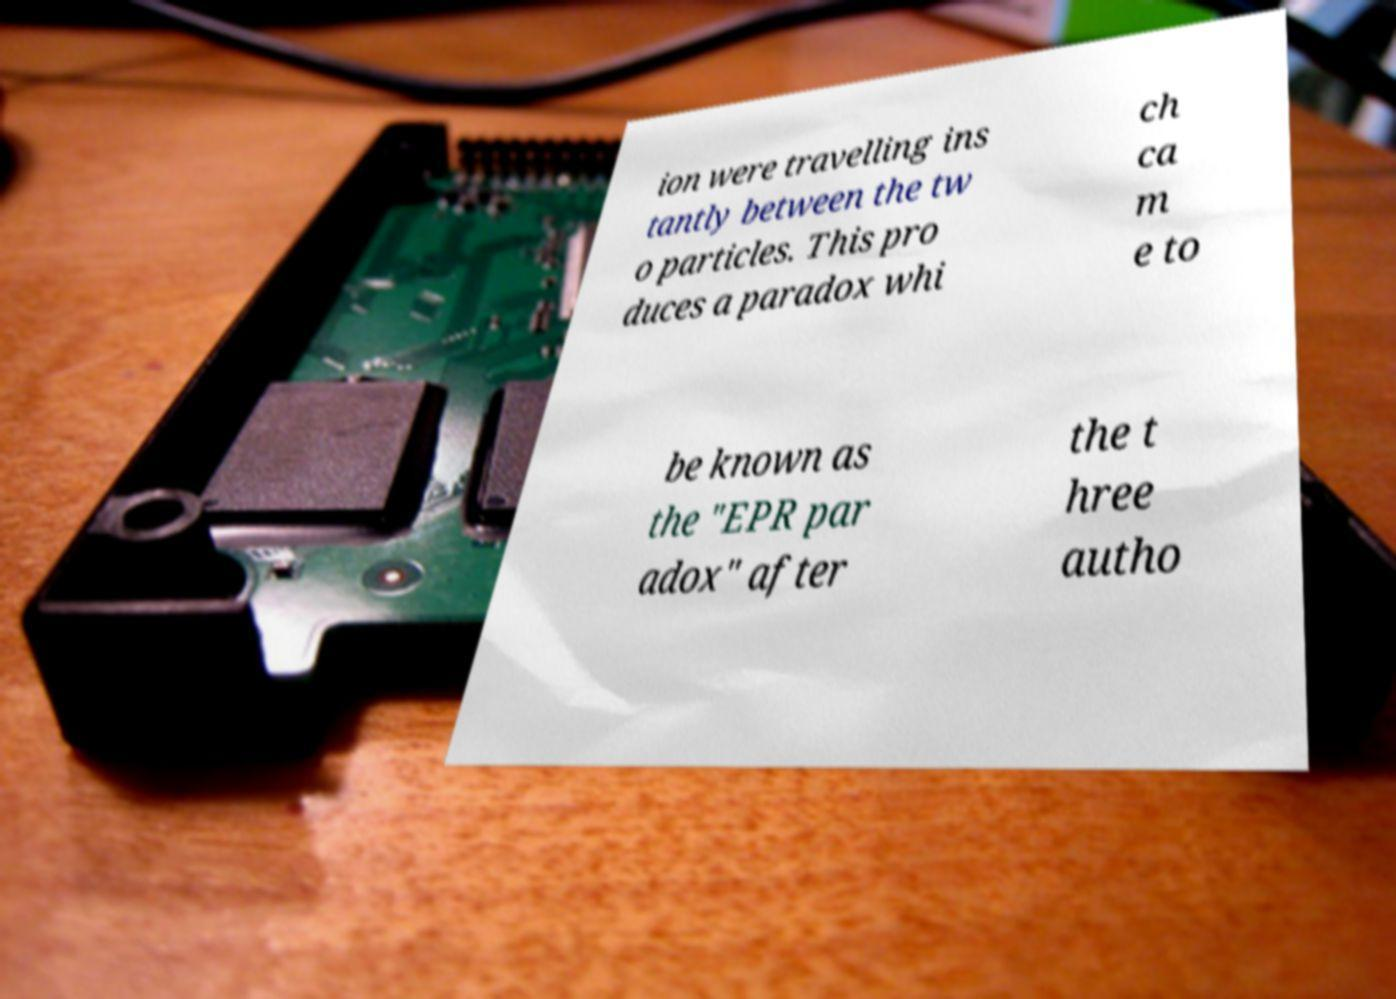What messages or text are displayed in this image? I need them in a readable, typed format. ion were travelling ins tantly between the tw o particles. This pro duces a paradox whi ch ca m e to be known as the "EPR par adox" after the t hree autho 